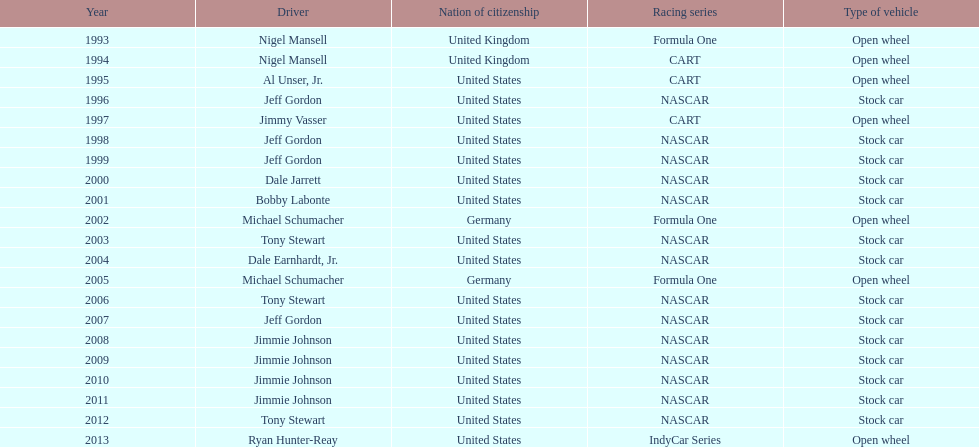Which chauffeur accomplished four continuous wins? Jimmie Johnson. 